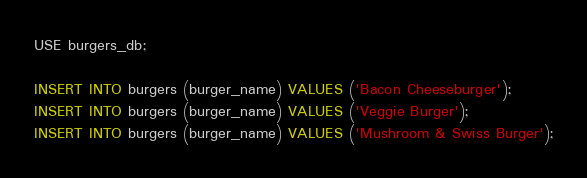Convert code to text. <code><loc_0><loc_0><loc_500><loc_500><_SQL_>USE burgers_db;

INSERT INTO burgers (burger_name) VALUES ('Bacon Cheeseburger');
INSERT INTO burgers (burger_name) VALUES ('Veggie Burger');
INSERT INTO burgers (burger_name) VALUES ('Mushroom & Swiss Burger');</code> 